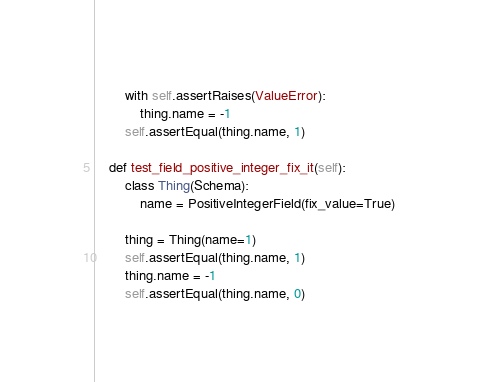<code> <loc_0><loc_0><loc_500><loc_500><_Python_>        with self.assertRaises(ValueError):
            thing.name = -1
        self.assertEqual(thing.name, 1)

    def test_field_positive_integer_fix_it(self):
        class Thing(Schema):
            name = PositiveIntegerField(fix_value=True)

        thing = Thing(name=1)
        self.assertEqual(thing.name, 1)
        thing.name = -1
        self.assertEqual(thing.name, 0)
</code> 